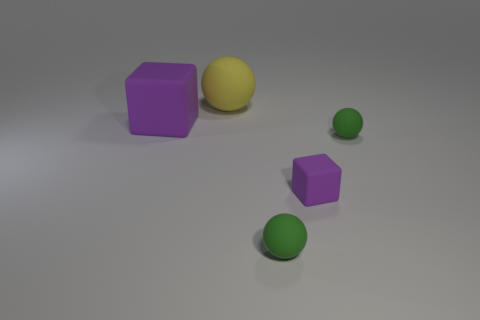Add 5 purple matte objects. How many objects exist? 10 Subtract all cubes. How many objects are left? 3 Add 1 yellow rubber things. How many yellow rubber things exist? 2 Subtract 0 blue cubes. How many objects are left? 5 Subtract all large spheres. Subtract all small rubber balls. How many objects are left? 2 Add 4 yellow matte balls. How many yellow matte balls are left? 5 